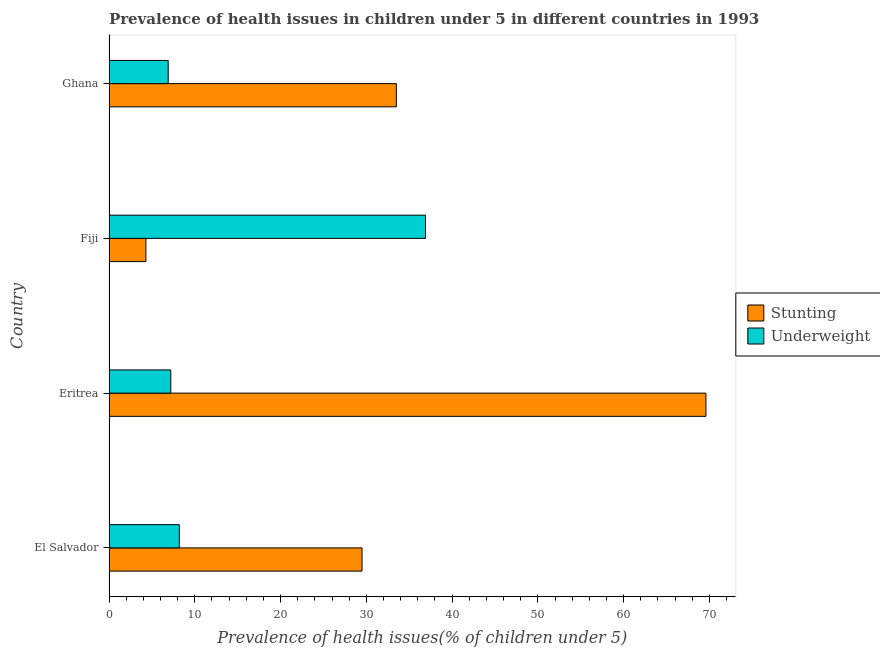Are the number of bars on each tick of the Y-axis equal?
Give a very brief answer. Yes. How many bars are there on the 3rd tick from the top?
Make the answer very short. 2. How many bars are there on the 4th tick from the bottom?
Provide a succinct answer. 2. What is the label of the 4th group of bars from the top?
Give a very brief answer. El Salvador. In how many cases, is the number of bars for a given country not equal to the number of legend labels?
Ensure brevity in your answer.  0. What is the percentage of stunted children in El Salvador?
Give a very brief answer. 29.5. Across all countries, what is the maximum percentage of underweight children?
Provide a succinct answer. 36.9. Across all countries, what is the minimum percentage of underweight children?
Your answer should be compact. 6.9. In which country was the percentage of stunted children maximum?
Your answer should be very brief. Eritrea. In which country was the percentage of stunted children minimum?
Offer a very short reply. Fiji. What is the total percentage of underweight children in the graph?
Give a very brief answer. 59.2. What is the difference between the percentage of stunted children in Eritrea and that in Ghana?
Your answer should be very brief. 36.1. What is the difference between the percentage of underweight children in Eritrea and the percentage of stunted children in El Salvador?
Keep it short and to the point. -22.3. What is the average percentage of stunted children per country?
Your answer should be compact. 34.23. What is the difference between the percentage of stunted children and percentage of underweight children in Fiji?
Your answer should be very brief. -32.6. What is the ratio of the percentage of underweight children in El Salvador to that in Ghana?
Keep it short and to the point. 1.19. Is the difference between the percentage of stunted children in Eritrea and Fiji greater than the difference between the percentage of underweight children in Eritrea and Fiji?
Provide a short and direct response. Yes. What is the difference between the highest and the second highest percentage of underweight children?
Your answer should be very brief. 28.7. In how many countries, is the percentage of underweight children greater than the average percentage of underweight children taken over all countries?
Give a very brief answer. 1. Is the sum of the percentage of stunted children in El Salvador and Ghana greater than the maximum percentage of underweight children across all countries?
Offer a very short reply. Yes. What does the 2nd bar from the top in Eritrea represents?
Offer a very short reply. Stunting. What does the 1st bar from the bottom in El Salvador represents?
Give a very brief answer. Stunting. How many bars are there?
Offer a very short reply. 8. Are the values on the major ticks of X-axis written in scientific E-notation?
Your response must be concise. No. Does the graph contain grids?
Provide a short and direct response. No. What is the title of the graph?
Keep it short and to the point. Prevalence of health issues in children under 5 in different countries in 1993. Does "Lowest 10% of population" appear as one of the legend labels in the graph?
Your answer should be very brief. No. What is the label or title of the X-axis?
Keep it short and to the point. Prevalence of health issues(% of children under 5). What is the Prevalence of health issues(% of children under 5) in Stunting in El Salvador?
Provide a short and direct response. 29.5. What is the Prevalence of health issues(% of children under 5) of Underweight in El Salvador?
Provide a succinct answer. 8.2. What is the Prevalence of health issues(% of children under 5) of Stunting in Eritrea?
Your answer should be compact. 69.6. What is the Prevalence of health issues(% of children under 5) of Underweight in Eritrea?
Make the answer very short. 7.2. What is the Prevalence of health issues(% of children under 5) of Stunting in Fiji?
Provide a succinct answer. 4.3. What is the Prevalence of health issues(% of children under 5) of Underweight in Fiji?
Give a very brief answer. 36.9. What is the Prevalence of health issues(% of children under 5) of Stunting in Ghana?
Keep it short and to the point. 33.5. What is the Prevalence of health issues(% of children under 5) of Underweight in Ghana?
Give a very brief answer. 6.9. Across all countries, what is the maximum Prevalence of health issues(% of children under 5) in Stunting?
Keep it short and to the point. 69.6. Across all countries, what is the maximum Prevalence of health issues(% of children under 5) of Underweight?
Make the answer very short. 36.9. Across all countries, what is the minimum Prevalence of health issues(% of children under 5) in Stunting?
Give a very brief answer. 4.3. Across all countries, what is the minimum Prevalence of health issues(% of children under 5) in Underweight?
Keep it short and to the point. 6.9. What is the total Prevalence of health issues(% of children under 5) in Stunting in the graph?
Offer a very short reply. 136.9. What is the total Prevalence of health issues(% of children under 5) in Underweight in the graph?
Keep it short and to the point. 59.2. What is the difference between the Prevalence of health issues(% of children under 5) in Stunting in El Salvador and that in Eritrea?
Your answer should be very brief. -40.1. What is the difference between the Prevalence of health issues(% of children under 5) of Stunting in El Salvador and that in Fiji?
Your response must be concise. 25.2. What is the difference between the Prevalence of health issues(% of children under 5) of Underweight in El Salvador and that in Fiji?
Provide a short and direct response. -28.7. What is the difference between the Prevalence of health issues(% of children under 5) of Underweight in El Salvador and that in Ghana?
Make the answer very short. 1.3. What is the difference between the Prevalence of health issues(% of children under 5) of Stunting in Eritrea and that in Fiji?
Offer a very short reply. 65.3. What is the difference between the Prevalence of health issues(% of children under 5) in Underweight in Eritrea and that in Fiji?
Offer a very short reply. -29.7. What is the difference between the Prevalence of health issues(% of children under 5) in Stunting in Eritrea and that in Ghana?
Give a very brief answer. 36.1. What is the difference between the Prevalence of health issues(% of children under 5) in Stunting in Fiji and that in Ghana?
Keep it short and to the point. -29.2. What is the difference between the Prevalence of health issues(% of children under 5) in Underweight in Fiji and that in Ghana?
Your answer should be very brief. 30. What is the difference between the Prevalence of health issues(% of children under 5) in Stunting in El Salvador and the Prevalence of health issues(% of children under 5) in Underweight in Eritrea?
Give a very brief answer. 22.3. What is the difference between the Prevalence of health issues(% of children under 5) of Stunting in El Salvador and the Prevalence of health issues(% of children under 5) of Underweight in Ghana?
Provide a succinct answer. 22.6. What is the difference between the Prevalence of health issues(% of children under 5) of Stunting in Eritrea and the Prevalence of health issues(% of children under 5) of Underweight in Fiji?
Ensure brevity in your answer.  32.7. What is the difference between the Prevalence of health issues(% of children under 5) in Stunting in Eritrea and the Prevalence of health issues(% of children under 5) in Underweight in Ghana?
Make the answer very short. 62.7. What is the difference between the Prevalence of health issues(% of children under 5) of Stunting in Fiji and the Prevalence of health issues(% of children under 5) of Underweight in Ghana?
Your response must be concise. -2.6. What is the average Prevalence of health issues(% of children under 5) in Stunting per country?
Keep it short and to the point. 34.23. What is the average Prevalence of health issues(% of children under 5) in Underweight per country?
Make the answer very short. 14.8. What is the difference between the Prevalence of health issues(% of children under 5) of Stunting and Prevalence of health issues(% of children under 5) of Underweight in El Salvador?
Provide a short and direct response. 21.3. What is the difference between the Prevalence of health issues(% of children under 5) in Stunting and Prevalence of health issues(% of children under 5) in Underweight in Eritrea?
Your answer should be compact. 62.4. What is the difference between the Prevalence of health issues(% of children under 5) of Stunting and Prevalence of health issues(% of children under 5) of Underweight in Fiji?
Your answer should be compact. -32.6. What is the difference between the Prevalence of health issues(% of children under 5) of Stunting and Prevalence of health issues(% of children under 5) of Underweight in Ghana?
Provide a succinct answer. 26.6. What is the ratio of the Prevalence of health issues(% of children under 5) in Stunting in El Salvador to that in Eritrea?
Give a very brief answer. 0.42. What is the ratio of the Prevalence of health issues(% of children under 5) of Underweight in El Salvador to that in Eritrea?
Offer a very short reply. 1.14. What is the ratio of the Prevalence of health issues(% of children under 5) in Stunting in El Salvador to that in Fiji?
Ensure brevity in your answer.  6.86. What is the ratio of the Prevalence of health issues(% of children under 5) of Underweight in El Salvador to that in Fiji?
Offer a terse response. 0.22. What is the ratio of the Prevalence of health issues(% of children under 5) of Stunting in El Salvador to that in Ghana?
Your answer should be very brief. 0.88. What is the ratio of the Prevalence of health issues(% of children under 5) in Underweight in El Salvador to that in Ghana?
Provide a succinct answer. 1.19. What is the ratio of the Prevalence of health issues(% of children under 5) in Stunting in Eritrea to that in Fiji?
Make the answer very short. 16.19. What is the ratio of the Prevalence of health issues(% of children under 5) in Underweight in Eritrea to that in Fiji?
Provide a succinct answer. 0.2. What is the ratio of the Prevalence of health issues(% of children under 5) of Stunting in Eritrea to that in Ghana?
Your response must be concise. 2.08. What is the ratio of the Prevalence of health issues(% of children under 5) in Underweight in Eritrea to that in Ghana?
Offer a terse response. 1.04. What is the ratio of the Prevalence of health issues(% of children under 5) of Stunting in Fiji to that in Ghana?
Offer a terse response. 0.13. What is the ratio of the Prevalence of health issues(% of children under 5) in Underweight in Fiji to that in Ghana?
Your answer should be compact. 5.35. What is the difference between the highest and the second highest Prevalence of health issues(% of children under 5) of Stunting?
Your answer should be compact. 36.1. What is the difference between the highest and the second highest Prevalence of health issues(% of children under 5) of Underweight?
Offer a terse response. 28.7. What is the difference between the highest and the lowest Prevalence of health issues(% of children under 5) in Stunting?
Your response must be concise. 65.3. What is the difference between the highest and the lowest Prevalence of health issues(% of children under 5) in Underweight?
Your response must be concise. 30. 